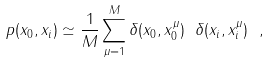<formula> <loc_0><loc_0><loc_500><loc_500>p ( x _ { 0 } , x _ { i } ) \simeq \frac { 1 } { M } \sum _ { \mu = 1 } ^ { M } \delta ( x _ { 0 } , x _ { 0 } ^ { \mu } ) \ \delta ( x _ { i } , x _ { i } ^ { \mu } ) \ ,</formula> 